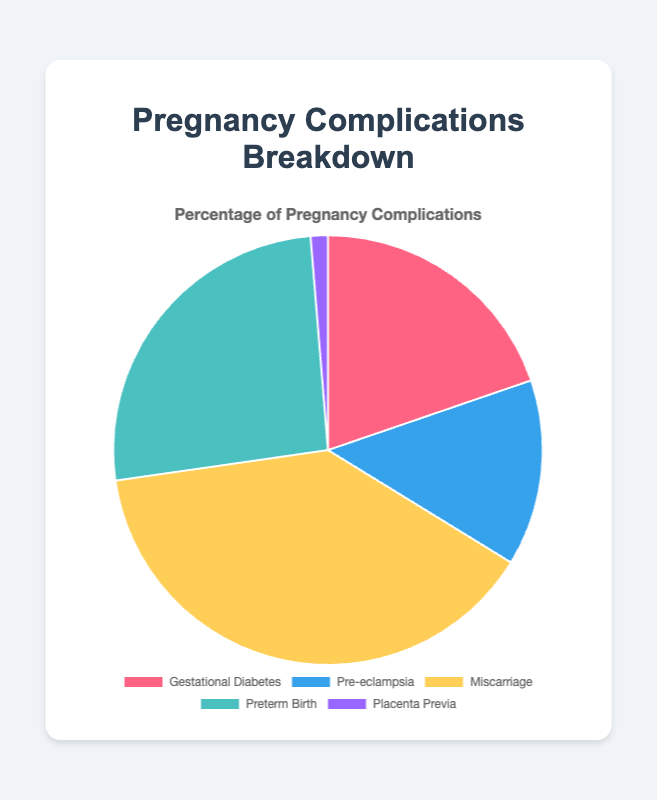What are the two most common pregnancy complications? The pie chart shows the percentage distribution of different pregnancy complications. Miscarriage has the highest percentage at 15.0%, followed by Preterm Birth at 10.0%.
Answer: Miscarriage and Preterm Birth Which complication is least common? The pie chart lists the percentages for different pregnancy complications. Placenta Previa has the lowest percentage at 0.5%.
Answer: Placenta Previa How much higher is the percentage of Miscarriage compared to Pre-eclampsia? Miscarriage is at 15.0% while Pre-eclampsia is at 5.4%. The difference is 15.0% - 5.4% = 9.6%.
Answer: 9.6% What is the combined percentage of Gestational Diabetes and Preterm Birth? Gestational Diabetes is at 7.6% and Preterm Birth is at 10.0%. Adding these together gives 7.6% + 10.0% = 17.6%.
Answer: 17.6% Which complication has a slightly higher percentage than Gestational Diabetes? Gestational Diabetes has a percentage of 7.6%. Preterm Birth, which is at 10.0%, is slightly higher.
Answer: Preterm Birth Is the percentage of Pre-eclampsia more or less than half of Miscarriage? Miscarriage is at 15.0%. Half of this would be 15.0% / 2 = 7.5%. Pre-eclampsia is at 5.4%, which is less than 7.5%.
Answer: Less Which complication is represented by the color red in the pie chart? The color red represents Gestational Diabetes in the pie chart.
Answer: Gestational Diabetes What is the average percentage of all listed complications? The percentages of the complications are: 7.6%, 5.4%, 15.0%, 10.0%, and 0.5%. The sum is 7.6% + 5.4% + 15.0% + 10.0% + 0.5% = 38.5%. The average is 38.5% / 5 = 7.7%.
Answer: 7.7% How does the percentage of Preterm Birth compare to that of Gestational Diabetes? Preterm Birth has a percentage of 10.0%, while Gestational Diabetes is at 7.6%. Preterm Birth is higher.
Answer: Preterm Birth is higher If we combine the percentages of Pre-eclampsia and Placenta Previa, how does this compare to the percentage of Miscarriage? Pre-eclampsia is 5.4% and Placenta Previa is 0.5%, giving a combined percentage of 5.4% + 0.5% = 5.9%. Miscarriage is at 15.0%. So, 5.9% is much less than 15.0%.
Answer: 5.9% is much less 